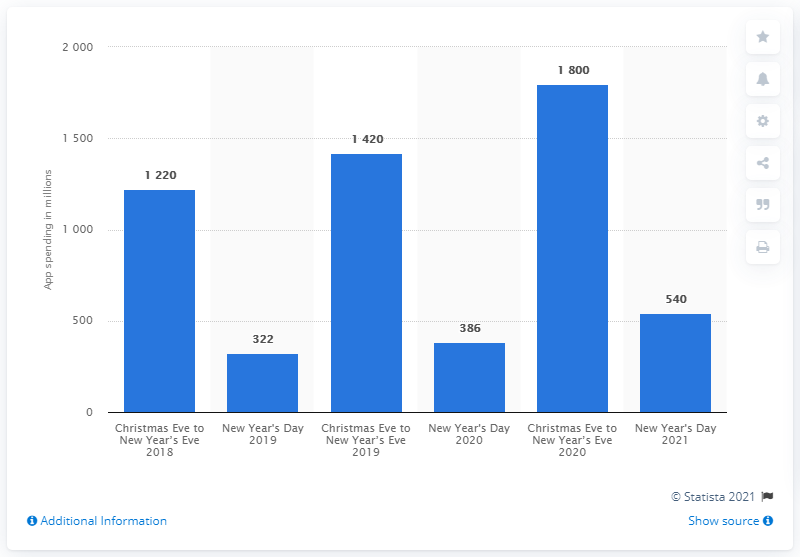Outline some significant characteristics in this image. Apple's App Store spent an estimated 1,800 million dollars between Christmas Eve and New Year's Eve of 2020. On New Year's Day 2021, customers spent a total of 540 dollars on iOS apps. 